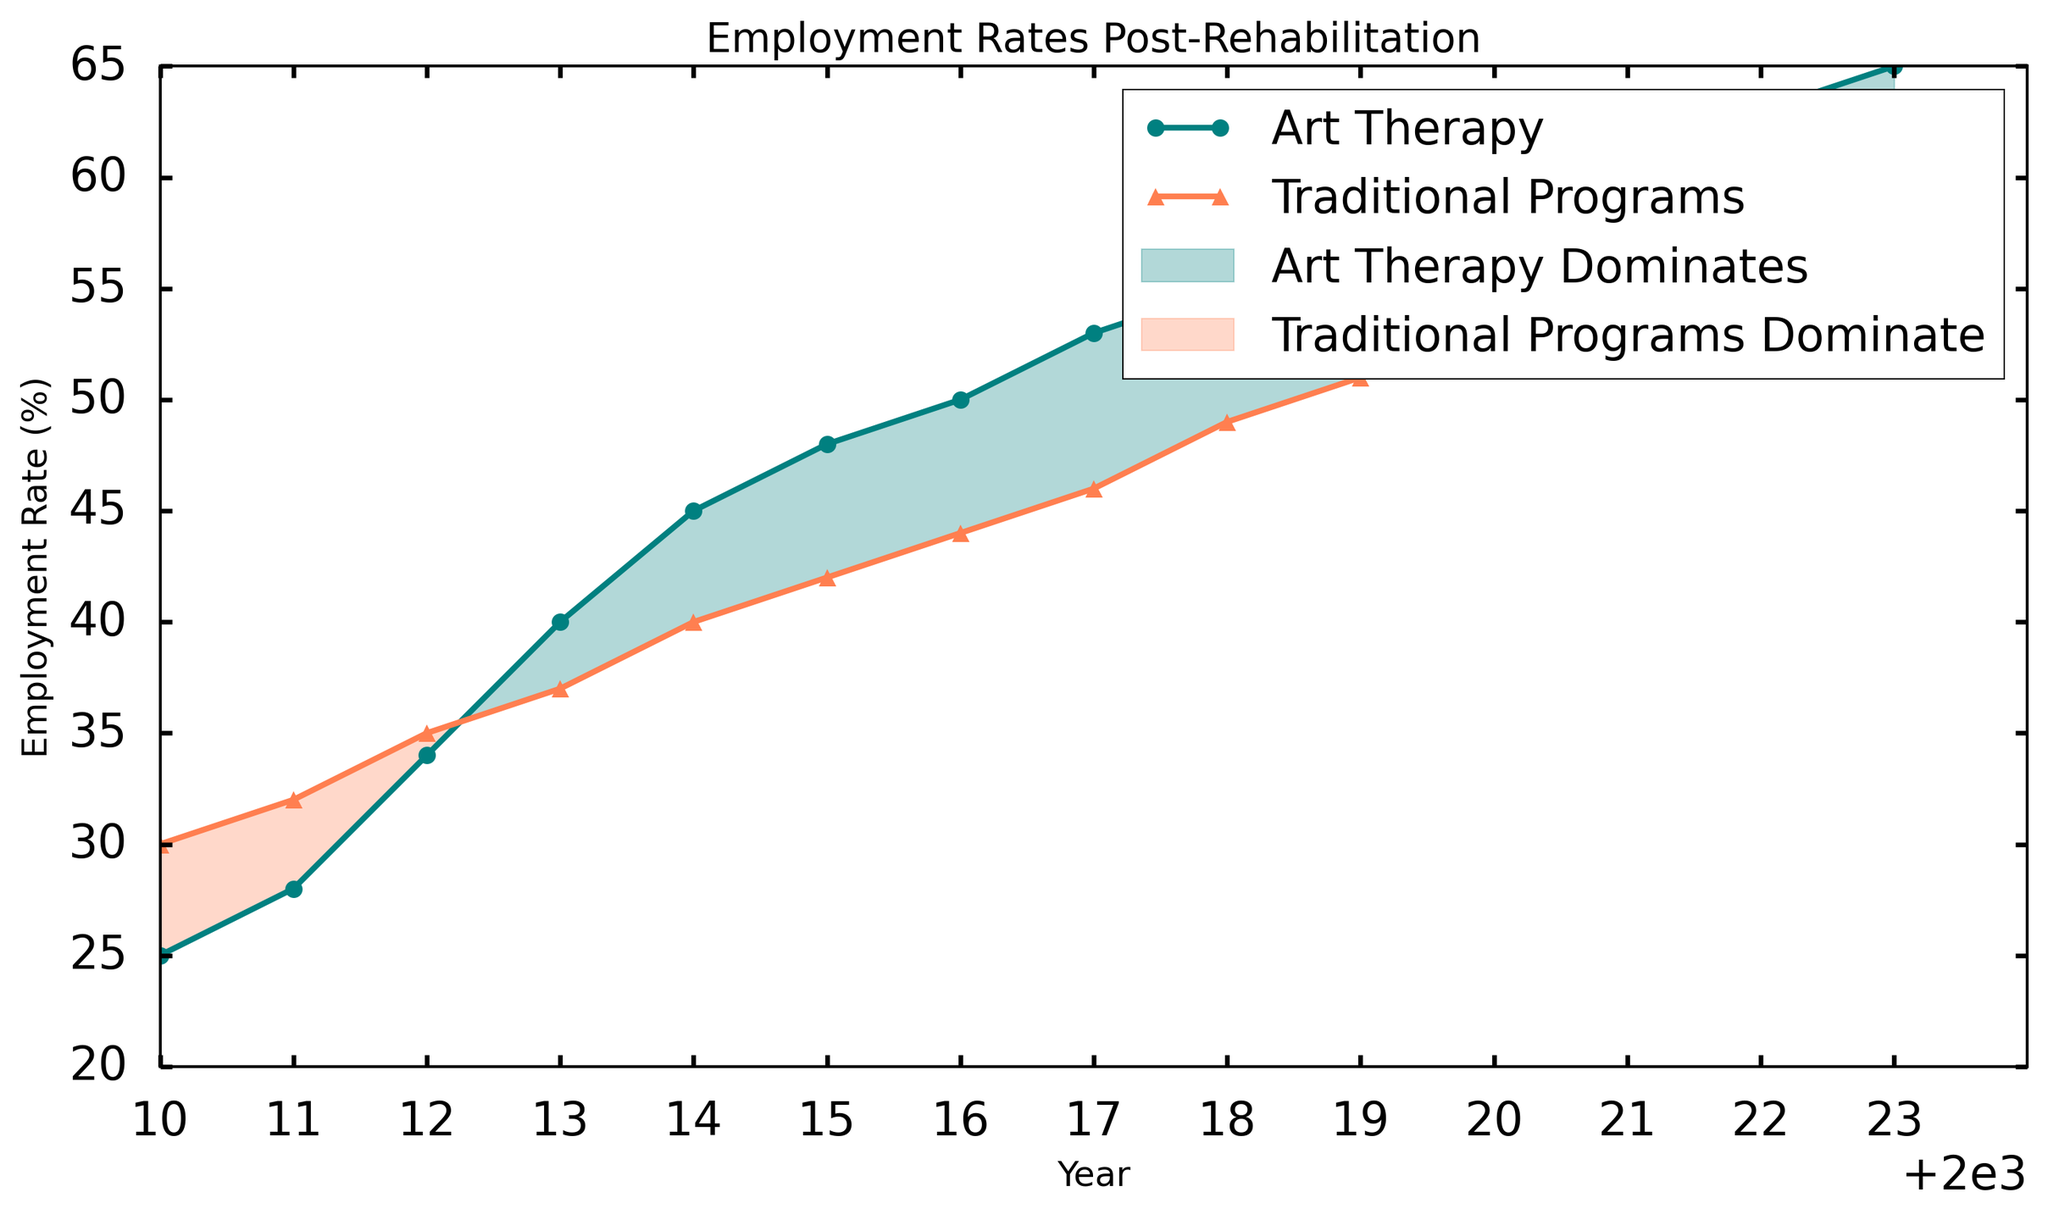What is the employment rate for art therapy in 2023? Look at the graph for the year 2023 and check the value for the 'Art Therapy' line.
Answer: 65 What is the difference in employment rates between art therapy and traditional programs in 2015? For 2015, the employment rate for art therapy is 48% and for traditional programs is 42%. The difference is 48% - 42% = 6%.
Answer: 6% In which year did art therapy first surpass the employment rate of traditional programs? Notice the point where the 'Art Therapy' line is higher than the 'Traditional Programs' line for the first time. This happens in 2012.
Answer: 2012 How many years did traditional programs have a higher employment rate than art therapy? Look for the periods where the 'Traditional Programs' line is above the 'Art Therapy' line. This occurs from 2010 to 2011, thus 2 years.
Answer: 2 What is the average employment rate for traditional programs from 2020 to 2023? Sum the employment rates from 2020 to 2023 for traditional programs: 52 + 53 + 54 + 55 = 214. Divide by 4 (number of years) to get the average. 214/4 = 53.5.
Answer: 53.5 Which fill color indicates periods where art therapy has a higher employment rate than traditional programs? The 'teal' shaded region indicates periods where 'Art Therapy' has higher employment rates compared to 'Traditional Programs'.
Answer: teal By how much did the employment rate for art therapy increase from 2010 to 2023? Subtract the employment rate of 'Art Therapy' in 2010 (25%) from that in 2023 (65%). 65% - 25% = 40%.
Answer: 40% Identify the years when both programs had the same employment rate. Locate any points where the 'Art Therapy' and 'Traditional Programs' lines intersect. This does not occur in the graph.
Answer: Never What is the employment rate trend for traditional programs from 2010 to 2023? Observe the 'Traditional Programs' line from 2010 to 2023. The line generally trends upward, indicating an increasing employment rate.
Answer: Increasing During which years did the employment rate for art therapy grow the fastest? Observe the steepest rise in the 'Art Therapy' line, which occurs between 2010 and 2013.
Answer: 2010-2013 